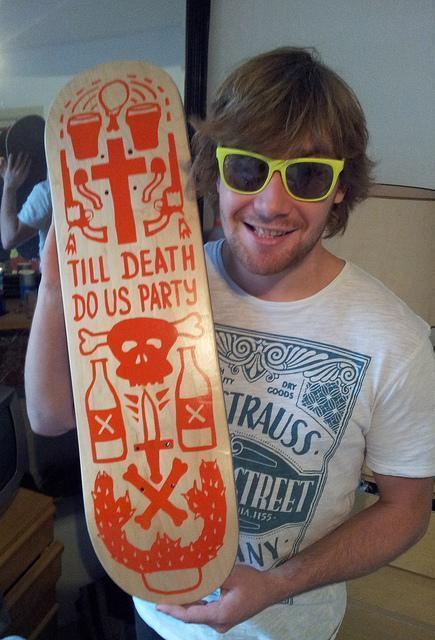How many people can you see?
Give a very brief answer. 2. How many skateboards are in the picture?
Give a very brief answer. 1. 